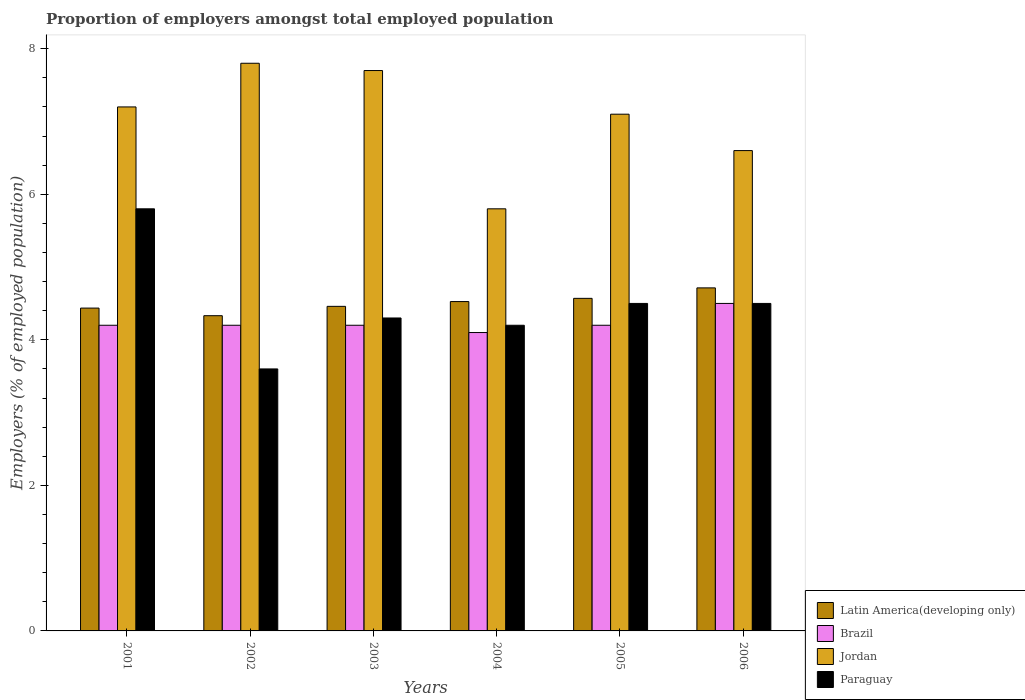How many different coloured bars are there?
Provide a short and direct response. 4. How many bars are there on the 1st tick from the left?
Your answer should be very brief. 4. What is the label of the 3rd group of bars from the left?
Keep it short and to the point. 2003. What is the proportion of employers in Brazil in 2006?
Provide a succinct answer. 4.5. Across all years, what is the maximum proportion of employers in Jordan?
Provide a short and direct response. 7.8. Across all years, what is the minimum proportion of employers in Latin America(developing only)?
Your response must be concise. 4.33. In which year was the proportion of employers in Paraguay maximum?
Give a very brief answer. 2001. In which year was the proportion of employers in Latin America(developing only) minimum?
Your answer should be compact. 2002. What is the total proportion of employers in Jordan in the graph?
Make the answer very short. 42.2. What is the difference between the proportion of employers in Jordan in 2002 and that in 2004?
Ensure brevity in your answer.  2. What is the difference between the proportion of employers in Brazil in 2003 and the proportion of employers in Paraguay in 2006?
Make the answer very short. -0.3. What is the average proportion of employers in Brazil per year?
Keep it short and to the point. 4.23. In the year 2004, what is the difference between the proportion of employers in Paraguay and proportion of employers in Brazil?
Your response must be concise. 0.1. What is the ratio of the proportion of employers in Brazil in 2002 to that in 2004?
Ensure brevity in your answer.  1.02. Is the proportion of employers in Jordan in 2001 less than that in 2002?
Your answer should be compact. Yes. Is the difference between the proportion of employers in Paraguay in 2003 and 2006 greater than the difference between the proportion of employers in Brazil in 2003 and 2006?
Ensure brevity in your answer.  Yes. What is the difference between the highest and the second highest proportion of employers in Brazil?
Provide a succinct answer. 0.3. What is the difference between the highest and the lowest proportion of employers in Paraguay?
Offer a very short reply. 2.2. In how many years, is the proportion of employers in Latin America(developing only) greater than the average proportion of employers in Latin America(developing only) taken over all years?
Your answer should be compact. 3. Is it the case that in every year, the sum of the proportion of employers in Jordan and proportion of employers in Brazil is greater than the sum of proportion of employers in Paraguay and proportion of employers in Latin America(developing only)?
Give a very brief answer. Yes. What does the 4th bar from the left in 2003 represents?
Ensure brevity in your answer.  Paraguay. What does the 2nd bar from the right in 2006 represents?
Provide a short and direct response. Jordan. Is it the case that in every year, the sum of the proportion of employers in Brazil and proportion of employers in Paraguay is greater than the proportion of employers in Jordan?
Keep it short and to the point. No. How many bars are there?
Your response must be concise. 24. Are all the bars in the graph horizontal?
Keep it short and to the point. No. How many years are there in the graph?
Offer a terse response. 6. Are the values on the major ticks of Y-axis written in scientific E-notation?
Ensure brevity in your answer.  No. Where does the legend appear in the graph?
Your response must be concise. Bottom right. How are the legend labels stacked?
Give a very brief answer. Vertical. What is the title of the graph?
Your response must be concise. Proportion of employers amongst total employed population. What is the label or title of the Y-axis?
Offer a very short reply. Employers (% of employed population). What is the Employers (% of employed population) in Latin America(developing only) in 2001?
Your answer should be very brief. 4.44. What is the Employers (% of employed population) in Brazil in 2001?
Ensure brevity in your answer.  4.2. What is the Employers (% of employed population) of Jordan in 2001?
Offer a very short reply. 7.2. What is the Employers (% of employed population) in Paraguay in 2001?
Provide a succinct answer. 5.8. What is the Employers (% of employed population) in Latin America(developing only) in 2002?
Offer a terse response. 4.33. What is the Employers (% of employed population) of Brazil in 2002?
Your answer should be compact. 4.2. What is the Employers (% of employed population) in Jordan in 2002?
Your response must be concise. 7.8. What is the Employers (% of employed population) in Paraguay in 2002?
Provide a succinct answer. 3.6. What is the Employers (% of employed population) of Latin America(developing only) in 2003?
Your answer should be very brief. 4.46. What is the Employers (% of employed population) in Brazil in 2003?
Make the answer very short. 4.2. What is the Employers (% of employed population) in Jordan in 2003?
Offer a very short reply. 7.7. What is the Employers (% of employed population) of Paraguay in 2003?
Offer a very short reply. 4.3. What is the Employers (% of employed population) of Latin America(developing only) in 2004?
Offer a very short reply. 4.53. What is the Employers (% of employed population) of Brazil in 2004?
Offer a terse response. 4.1. What is the Employers (% of employed population) in Jordan in 2004?
Provide a succinct answer. 5.8. What is the Employers (% of employed population) in Paraguay in 2004?
Your answer should be compact. 4.2. What is the Employers (% of employed population) of Latin America(developing only) in 2005?
Your response must be concise. 4.57. What is the Employers (% of employed population) in Brazil in 2005?
Give a very brief answer. 4.2. What is the Employers (% of employed population) in Jordan in 2005?
Make the answer very short. 7.1. What is the Employers (% of employed population) in Paraguay in 2005?
Offer a very short reply. 4.5. What is the Employers (% of employed population) in Latin America(developing only) in 2006?
Ensure brevity in your answer.  4.71. What is the Employers (% of employed population) of Brazil in 2006?
Offer a very short reply. 4.5. What is the Employers (% of employed population) in Jordan in 2006?
Make the answer very short. 6.6. What is the Employers (% of employed population) of Paraguay in 2006?
Your answer should be compact. 4.5. Across all years, what is the maximum Employers (% of employed population) of Latin America(developing only)?
Offer a very short reply. 4.71. Across all years, what is the maximum Employers (% of employed population) of Brazil?
Provide a short and direct response. 4.5. Across all years, what is the maximum Employers (% of employed population) of Jordan?
Provide a short and direct response. 7.8. Across all years, what is the maximum Employers (% of employed population) in Paraguay?
Your answer should be compact. 5.8. Across all years, what is the minimum Employers (% of employed population) of Latin America(developing only)?
Offer a terse response. 4.33. Across all years, what is the minimum Employers (% of employed population) of Brazil?
Provide a succinct answer. 4.1. Across all years, what is the minimum Employers (% of employed population) of Jordan?
Keep it short and to the point. 5.8. Across all years, what is the minimum Employers (% of employed population) of Paraguay?
Your answer should be compact. 3.6. What is the total Employers (% of employed population) in Latin America(developing only) in the graph?
Your answer should be compact. 27.04. What is the total Employers (% of employed population) in Brazil in the graph?
Give a very brief answer. 25.4. What is the total Employers (% of employed population) of Jordan in the graph?
Provide a succinct answer. 42.2. What is the total Employers (% of employed population) in Paraguay in the graph?
Your response must be concise. 26.9. What is the difference between the Employers (% of employed population) in Latin America(developing only) in 2001 and that in 2002?
Provide a short and direct response. 0.1. What is the difference between the Employers (% of employed population) in Paraguay in 2001 and that in 2002?
Provide a short and direct response. 2.2. What is the difference between the Employers (% of employed population) in Latin America(developing only) in 2001 and that in 2003?
Offer a terse response. -0.02. What is the difference between the Employers (% of employed population) in Latin America(developing only) in 2001 and that in 2004?
Ensure brevity in your answer.  -0.09. What is the difference between the Employers (% of employed population) of Brazil in 2001 and that in 2004?
Ensure brevity in your answer.  0.1. What is the difference between the Employers (% of employed population) of Latin America(developing only) in 2001 and that in 2005?
Offer a terse response. -0.13. What is the difference between the Employers (% of employed population) of Paraguay in 2001 and that in 2005?
Offer a terse response. 1.3. What is the difference between the Employers (% of employed population) of Latin America(developing only) in 2001 and that in 2006?
Your answer should be compact. -0.28. What is the difference between the Employers (% of employed population) in Jordan in 2001 and that in 2006?
Your answer should be compact. 0.6. What is the difference between the Employers (% of employed population) in Paraguay in 2001 and that in 2006?
Make the answer very short. 1.3. What is the difference between the Employers (% of employed population) of Latin America(developing only) in 2002 and that in 2003?
Provide a short and direct response. -0.13. What is the difference between the Employers (% of employed population) of Paraguay in 2002 and that in 2003?
Provide a short and direct response. -0.7. What is the difference between the Employers (% of employed population) in Latin America(developing only) in 2002 and that in 2004?
Provide a short and direct response. -0.19. What is the difference between the Employers (% of employed population) of Jordan in 2002 and that in 2004?
Offer a terse response. 2. What is the difference between the Employers (% of employed population) of Paraguay in 2002 and that in 2004?
Give a very brief answer. -0.6. What is the difference between the Employers (% of employed population) in Latin America(developing only) in 2002 and that in 2005?
Provide a succinct answer. -0.24. What is the difference between the Employers (% of employed population) in Brazil in 2002 and that in 2005?
Your answer should be very brief. 0. What is the difference between the Employers (% of employed population) in Jordan in 2002 and that in 2005?
Your response must be concise. 0.7. What is the difference between the Employers (% of employed population) in Paraguay in 2002 and that in 2005?
Give a very brief answer. -0.9. What is the difference between the Employers (% of employed population) in Latin America(developing only) in 2002 and that in 2006?
Keep it short and to the point. -0.38. What is the difference between the Employers (% of employed population) of Jordan in 2002 and that in 2006?
Make the answer very short. 1.2. What is the difference between the Employers (% of employed population) in Paraguay in 2002 and that in 2006?
Offer a terse response. -0.9. What is the difference between the Employers (% of employed population) in Latin America(developing only) in 2003 and that in 2004?
Provide a succinct answer. -0.07. What is the difference between the Employers (% of employed population) in Brazil in 2003 and that in 2004?
Your response must be concise. 0.1. What is the difference between the Employers (% of employed population) of Jordan in 2003 and that in 2004?
Provide a short and direct response. 1.9. What is the difference between the Employers (% of employed population) of Paraguay in 2003 and that in 2004?
Offer a terse response. 0.1. What is the difference between the Employers (% of employed population) of Latin America(developing only) in 2003 and that in 2005?
Your answer should be compact. -0.11. What is the difference between the Employers (% of employed population) in Latin America(developing only) in 2003 and that in 2006?
Ensure brevity in your answer.  -0.25. What is the difference between the Employers (% of employed population) in Jordan in 2003 and that in 2006?
Provide a short and direct response. 1.1. What is the difference between the Employers (% of employed population) of Latin America(developing only) in 2004 and that in 2005?
Offer a terse response. -0.04. What is the difference between the Employers (% of employed population) of Paraguay in 2004 and that in 2005?
Provide a succinct answer. -0.3. What is the difference between the Employers (% of employed population) of Latin America(developing only) in 2004 and that in 2006?
Your answer should be very brief. -0.19. What is the difference between the Employers (% of employed population) in Brazil in 2004 and that in 2006?
Offer a very short reply. -0.4. What is the difference between the Employers (% of employed population) in Latin America(developing only) in 2005 and that in 2006?
Keep it short and to the point. -0.14. What is the difference between the Employers (% of employed population) of Jordan in 2005 and that in 2006?
Give a very brief answer. 0.5. What is the difference between the Employers (% of employed population) in Latin America(developing only) in 2001 and the Employers (% of employed population) in Brazil in 2002?
Your response must be concise. 0.24. What is the difference between the Employers (% of employed population) in Latin America(developing only) in 2001 and the Employers (% of employed population) in Jordan in 2002?
Your response must be concise. -3.36. What is the difference between the Employers (% of employed population) in Latin America(developing only) in 2001 and the Employers (% of employed population) in Paraguay in 2002?
Make the answer very short. 0.84. What is the difference between the Employers (% of employed population) of Latin America(developing only) in 2001 and the Employers (% of employed population) of Brazil in 2003?
Provide a succinct answer. 0.24. What is the difference between the Employers (% of employed population) in Latin America(developing only) in 2001 and the Employers (% of employed population) in Jordan in 2003?
Your answer should be compact. -3.26. What is the difference between the Employers (% of employed population) in Latin America(developing only) in 2001 and the Employers (% of employed population) in Paraguay in 2003?
Your answer should be very brief. 0.14. What is the difference between the Employers (% of employed population) in Brazil in 2001 and the Employers (% of employed population) in Jordan in 2003?
Your answer should be very brief. -3.5. What is the difference between the Employers (% of employed population) of Latin America(developing only) in 2001 and the Employers (% of employed population) of Brazil in 2004?
Give a very brief answer. 0.34. What is the difference between the Employers (% of employed population) in Latin America(developing only) in 2001 and the Employers (% of employed population) in Jordan in 2004?
Offer a very short reply. -1.36. What is the difference between the Employers (% of employed population) in Latin America(developing only) in 2001 and the Employers (% of employed population) in Paraguay in 2004?
Offer a very short reply. 0.24. What is the difference between the Employers (% of employed population) of Brazil in 2001 and the Employers (% of employed population) of Paraguay in 2004?
Keep it short and to the point. 0. What is the difference between the Employers (% of employed population) of Latin America(developing only) in 2001 and the Employers (% of employed population) of Brazil in 2005?
Keep it short and to the point. 0.24. What is the difference between the Employers (% of employed population) of Latin America(developing only) in 2001 and the Employers (% of employed population) of Jordan in 2005?
Provide a short and direct response. -2.66. What is the difference between the Employers (% of employed population) of Latin America(developing only) in 2001 and the Employers (% of employed population) of Paraguay in 2005?
Offer a terse response. -0.06. What is the difference between the Employers (% of employed population) in Brazil in 2001 and the Employers (% of employed population) in Paraguay in 2005?
Keep it short and to the point. -0.3. What is the difference between the Employers (% of employed population) in Latin America(developing only) in 2001 and the Employers (% of employed population) in Brazil in 2006?
Provide a succinct answer. -0.06. What is the difference between the Employers (% of employed population) of Latin America(developing only) in 2001 and the Employers (% of employed population) of Jordan in 2006?
Ensure brevity in your answer.  -2.16. What is the difference between the Employers (% of employed population) in Latin America(developing only) in 2001 and the Employers (% of employed population) in Paraguay in 2006?
Ensure brevity in your answer.  -0.06. What is the difference between the Employers (% of employed population) in Brazil in 2001 and the Employers (% of employed population) in Paraguay in 2006?
Make the answer very short. -0.3. What is the difference between the Employers (% of employed population) of Latin America(developing only) in 2002 and the Employers (% of employed population) of Brazil in 2003?
Provide a short and direct response. 0.13. What is the difference between the Employers (% of employed population) of Latin America(developing only) in 2002 and the Employers (% of employed population) of Jordan in 2003?
Ensure brevity in your answer.  -3.37. What is the difference between the Employers (% of employed population) of Latin America(developing only) in 2002 and the Employers (% of employed population) of Paraguay in 2003?
Provide a short and direct response. 0.03. What is the difference between the Employers (% of employed population) in Brazil in 2002 and the Employers (% of employed population) in Jordan in 2003?
Your answer should be very brief. -3.5. What is the difference between the Employers (% of employed population) of Latin America(developing only) in 2002 and the Employers (% of employed population) of Brazil in 2004?
Ensure brevity in your answer.  0.23. What is the difference between the Employers (% of employed population) in Latin America(developing only) in 2002 and the Employers (% of employed population) in Jordan in 2004?
Provide a short and direct response. -1.47. What is the difference between the Employers (% of employed population) of Latin America(developing only) in 2002 and the Employers (% of employed population) of Paraguay in 2004?
Provide a short and direct response. 0.13. What is the difference between the Employers (% of employed population) of Brazil in 2002 and the Employers (% of employed population) of Jordan in 2004?
Offer a very short reply. -1.6. What is the difference between the Employers (% of employed population) in Brazil in 2002 and the Employers (% of employed population) in Paraguay in 2004?
Provide a short and direct response. 0. What is the difference between the Employers (% of employed population) in Jordan in 2002 and the Employers (% of employed population) in Paraguay in 2004?
Keep it short and to the point. 3.6. What is the difference between the Employers (% of employed population) in Latin America(developing only) in 2002 and the Employers (% of employed population) in Brazil in 2005?
Ensure brevity in your answer.  0.13. What is the difference between the Employers (% of employed population) in Latin America(developing only) in 2002 and the Employers (% of employed population) in Jordan in 2005?
Provide a succinct answer. -2.77. What is the difference between the Employers (% of employed population) of Latin America(developing only) in 2002 and the Employers (% of employed population) of Paraguay in 2005?
Your answer should be very brief. -0.17. What is the difference between the Employers (% of employed population) in Brazil in 2002 and the Employers (% of employed population) in Jordan in 2005?
Your answer should be very brief. -2.9. What is the difference between the Employers (% of employed population) in Jordan in 2002 and the Employers (% of employed population) in Paraguay in 2005?
Make the answer very short. 3.3. What is the difference between the Employers (% of employed population) of Latin America(developing only) in 2002 and the Employers (% of employed population) of Brazil in 2006?
Make the answer very short. -0.17. What is the difference between the Employers (% of employed population) of Latin America(developing only) in 2002 and the Employers (% of employed population) of Jordan in 2006?
Your answer should be very brief. -2.27. What is the difference between the Employers (% of employed population) of Latin America(developing only) in 2002 and the Employers (% of employed population) of Paraguay in 2006?
Ensure brevity in your answer.  -0.17. What is the difference between the Employers (% of employed population) of Brazil in 2002 and the Employers (% of employed population) of Jordan in 2006?
Your answer should be compact. -2.4. What is the difference between the Employers (% of employed population) of Brazil in 2002 and the Employers (% of employed population) of Paraguay in 2006?
Ensure brevity in your answer.  -0.3. What is the difference between the Employers (% of employed population) of Latin America(developing only) in 2003 and the Employers (% of employed population) of Brazil in 2004?
Keep it short and to the point. 0.36. What is the difference between the Employers (% of employed population) in Latin America(developing only) in 2003 and the Employers (% of employed population) in Jordan in 2004?
Ensure brevity in your answer.  -1.34. What is the difference between the Employers (% of employed population) of Latin America(developing only) in 2003 and the Employers (% of employed population) of Paraguay in 2004?
Your answer should be compact. 0.26. What is the difference between the Employers (% of employed population) in Brazil in 2003 and the Employers (% of employed population) in Jordan in 2004?
Your answer should be very brief. -1.6. What is the difference between the Employers (% of employed population) in Brazil in 2003 and the Employers (% of employed population) in Paraguay in 2004?
Give a very brief answer. 0. What is the difference between the Employers (% of employed population) in Latin America(developing only) in 2003 and the Employers (% of employed population) in Brazil in 2005?
Keep it short and to the point. 0.26. What is the difference between the Employers (% of employed population) of Latin America(developing only) in 2003 and the Employers (% of employed population) of Jordan in 2005?
Provide a short and direct response. -2.64. What is the difference between the Employers (% of employed population) in Latin America(developing only) in 2003 and the Employers (% of employed population) in Paraguay in 2005?
Keep it short and to the point. -0.04. What is the difference between the Employers (% of employed population) of Latin America(developing only) in 2003 and the Employers (% of employed population) of Brazil in 2006?
Give a very brief answer. -0.04. What is the difference between the Employers (% of employed population) of Latin America(developing only) in 2003 and the Employers (% of employed population) of Jordan in 2006?
Provide a short and direct response. -2.14. What is the difference between the Employers (% of employed population) of Latin America(developing only) in 2003 and the Employers (% of employed population) of Paraguay in 2006?
Provide a short and direct response. -0.04. What is the difference between the Employers (% of employed population) of Brazil in 2003 and the Employers (% of employed population) of Jordan in 2006?
Make the answer very short. -2.4. What is the difference between the Employers (% of employed population) of Brazil in 2003 and the Employers (% of employed population) of Paraguay in 2006?
Keep it short and to the point. -0.3. What is the difference between the Employers (% of employed population) of Jordan in 2003 and the Employers (% of employed population) of Paraguay in 2006?
Offer a very short reply. 3.2. What is the difference between the Employers (% of employed population) of Latin America(developing only) in 2004 and the Employers (% of employed population) of Brazil in 2005?
Give a very brief answer. 0.33. What is the difference between the Employers (% of employed population) of Latin America(developing only) in 2004 and the Employers (% of employed population) of Jordan in 2005?
Keep it short and to the point. -2.57. What is the difference between the Employers (% of employed population) of Latin America(developing only) in 2004 and the Employers (% of employed population) of Paraguay in 2005?
Offer a terse response. 0.03. What is the difference between the Employers (% of employed population) in Latin America(developing only) in 2004 and the Employers (% of employed population) in Brazil in 2006?
Your answer should be compact. 0.03. What is the difference between the Employers (% of employed population) in Latin America(developing only) in 2004 and the Employers (% of employed population) in Jordan in 2006?
Your answer should be very brief. -2.07. What is the difference between the Employers (% of employed population) in Latin America(developing only) in 2004 and the Employers (% of employed population) in Paraguay in 2006?
Ensure brevity in your answer.  0.03. What is the difference between the Employers (% of employed population) in Latin America(developing only) in 2005 and the Employers (% of employed population) in Brazil in 2006?
Make the answer very short. 0.07. What is the difference between the Employers (% of employed population) in Latin America(developing only) in 2005 and the Employers (% of employed population) in Jordan in 2006?
Provide a succinct answer. -2.03. What is the difference between the Employers (% of employed population) of Latin America(developing only) in 2005 and the Employers (% of employed population) of Paraguay in 2006?
Provide a succinct answer. 0.07. What is the difference between the Employers (% of employed population) of Jordan in 2005 and the Employers (% of employed population) of Paraguay in 2006?
Your answer should be compact. 2.6. What is the average Employers (% of employed population) in Latin America(developing only) per year?
Your answer should be very brief. 4.51. What is the average Employers (% of employed population) of Brazil per year?
Give a very brief answer. 4.23. What is the average Employers (% of employed population) of Jordan per year?
Your answer should be very brief. 7.03. What is the average Employers (% of employed population) in Paraguay per year?
Offer a very short reply. 4.48. In the year 2001, what is the difference between the Employers (% of employed population) of Latin America(developing only) and Employers (% of employed population) of Brazil?
Offer a terse response. 0.24. In the year 2001, what is the difference between the Employers (% of employed population) in Latin America(developing only) and Employers (% of employed population) in Jordan?
Your response must be concise. -2.76. In the year 2001, what is the difference between the Employers (% of employed population) of Latin America(developing only) and Employers (% of employed population) of Paraguay?
Your response must be concise. -1.36. In the year 2002, what is the difference between the Employers (% of employed population) of Latin America(developing only) and Employers (% of employed population) of Brazil?
Provide a succinct answer. 0.13. In the year 2002, what is the difference between the Employers (% of employed population) in Latin America(developing only) and Employers (% of employed population) in Jordan?
Your answer should be very brief. -3.47. In the year 2002, what is the difference between the Employers (% of employed population) of Latin America(developing only) and Employers (% of employed population) of Paraguay?
Ensure brevity in your answer.  0.73. In the year 2002, what is the difference between the Employers (% of employed population) in Brazil and Employers (% of employed population) in Paraguay?
Your response must be concise. 0.6. In the year 2002, what is the difference between the Employers (% of employed population) of Jordan and Employers (% of employed population) of Paraguay?
Keep it short and to the point. 4.2. In the year 2003, what is the difference between the Employers (% of employed population) in Latin America(developing only) and Employers (% of employed population) in Brazil?
Offer a terse response. 0.26. In the year 2003, what is the difference between the Employers (% of employed population) of Latin America(developing only) and Employers (% of employed population) of Jordan?
Your response must be concise. -3.24. In the year 2003, what is the difference between the Employers (% of employed population) of Latin America(developing only) and Employers (% of employed population) of Paraguay?
Offer a very short reply. 0.16. In the year 2004, what is the difference between the Employers (% of employed population) of Latin America(developing only) and Employers (% of employed population) of Brazil?
Ensure brevity in your answer.  0.43. In the year 2004, what is the difference between the Employers (% of employed population) of Latin America(developing only) and Employers (% of employed population) of Jordan?
Provide a short and direct response. -1.27. In the year 2004, what is the difference between the Employers (% of employed population) in Latin America(developing only) and Employers (% of employed population) in Paraguay?
Offer a terse response. 0.33. In the year 2004, what is the difference between the Employers (% of employed population) in Brazil and Employers (% of employed population) in Jordan?
Your response must be concise. -1.7. In the year 2004, what is the difference between the Employers (% of employed population) of Brazil and Employers (% of employed population) of Paraguay?
Keep it short and to the point. -0.1. In the year 2005, what is the difference between the Employers (% of employed population) in Latin America(developing only) and Employers (% of employed population) in Brazil?
Provide a succinct answer. 0.37. In the year 2005, what is the difference between the Employers (% of employed population) of Latin America(developing only) and Employers (% of employed population) of Jordan?
Make the answer very short. -2.53. In the year 2005, what is the difference between the Employers (% of employed population) in Latin America(developing only) and Employers (% of employed population) in Paraguay?
Offer a very short reply. 0.07. In the year 2005, what is the difference between the Employers (% of employed population) in Brazil and Employers (% of employed population) in Paraguay?
Offer a terse response. -0.3. In the year 2006, what is the difference between the Employers (% of employed population) of Latin America(developing only) and Employers (% of employed population) of Brazil?
Ensure brevity in your answer.  0.21. In the year 2006, what is the difference between the Employers (% of employed population) of Latin America(developing only) and Employers (% of employed population) of Jordan?
Offer a terse response. -1.89. In the year 2006, what is the difference between the Employers (% of employed population) in Latin America(developing only) and Employers (% of employed population) in Paraguay?
Offer a very short reply. 0.21. In the year 2006, what is the difference between the Employers (% of employed population) of Brazil and Employers (% of employed population) of Jordan?
Make the answer very short. -2.1. What is the ratio of the Employers (% of employed population) in Latin America(developing only) in 2001 to that in 2002?
Keep it short and to the point. 1.02. What is the ratio of the Employers (% of employed population) in Brazil in 2001 to that in 2002?
Make the answer very short. 1. What is the ratio of the Employers (% of employed population) in Jordan in 2001 to that in 2002?
Ensure brevity in your answer.  0.92. What is the ratio of the Employers (% of employed population) in Paraguay in 2001 to that in 2002?
Make the answer very short. 1.61. What is the ratio of the Employers (% of employed population) of Brazil in 2001 to that in 2003?
Ensure brevity in your answer.  1. What is the ratio of the Employers (% of employed population) in Jordan in 2001 to that in 2003?
Ensure brevity in your answer.  0.94. What is the ratio of the Employers (% of employed population) of Paraguay in 2001 to that in 2003?
Your response must be concise. 1.35. What is the ratio of the Employers (% of employed population) in Latin America(developing only) in 2001 to that in 2004?
Offer a very short reply. 0.98. What is the ratio of the Employers (% of employed population) of Brazil in 2001 to that in 2004?
Keep it short and to the point. 1.02. What is the ratio of the Employers (% of employed population) in Jordan in 2001 to that in 2004?
Provide a succinct answer. 1.24. What is the ratio of the Employers (% of employed population) of Paraguay in 2001 to that in 2004?
Make the answer very short. 1.38. What is the ratio of the Employers (% of employed population) of Latin America(developing only) in 2001 to that in 2005?
Offer a terse response. 0.97. What is the ratio of the Employers (% of employed population) in Brazil in 2001 to that in 2005?
Give a very brief answer. 1. What is the ratio of the Employers (% of employed population) of Jordan in 2001 to that in 2005?
Provide a short and direct response. 1.01. What is the ratio of the Employers (% of employed population) in Paraguay in 2001 to that in 2005?
Make the answer very short. 1.29. What is the ratio of the Employers (% of employed population) in Latin America(developing only) in 2001 to that in 2006?
Your response must be concise. 0.94. What is the ratio of the Employers (% of employed population) in Paraguay in 2001 to that in 2006?
Your answer should be very brief. 1.29. What is the ratio of the Employers (% of employed population) of Latin America(developing only) in 2002 to that in 2003?
Your answer should be compact. 0.97. What is the ratio of the Employers (% of employed population) of Brazil in 2002 to that in 2003?
Keep it short and to the point. 1. What is the ratio of the Employers (% of employed population) in Paraguay in 2002 to that in 2003?
Your answer should be very brief. 0.84. What is the ratio of the Employers (% of employed population) of Latin America(developing only) in 2002 to that in 2004?
Your response must be concise. 0.96. What is the ratio of the Employers (% of employed population) of Brazil in 2002 to that in 2004?
Make the answer very short. 1.02. What is the ratio of the Employers (% of employed population) of Jordan in 2002 to that in 2004?
Your response must be concise. 1.34. What is the ratio of the Employers (% of employed population) in Paraguay in 2002 to that in 2004?
Your response must be concise. 0.86. What is the ratio of the Employers (% of employed population) of Latin America(developing only) in 2002 to that in 2005?
Your answer should be very brief. 0.95. What is the ratio of the Employers (% of employed population) of Brazil in 2002 to that in 2005?
Keep it short and to the point. 1. What is the ratio of the Employers (% of employed population) in Jordan in 2002 to that in 2005?
Give a very brief answer. 1.1. What is the ratio of the Employers (% of employed population) of Paraguay in 2002 to that in 2005?
Provide a short and direct response. 0.8. What is the ratio of the Employers (% of employed population) in Latin America(developing only) in 2002 to that in 2006?
Offer a very short reply. 0.92. What is the ratio of the Employers (% of employed population) of Brazil in 2002 to that in 2006?
Provide a succinct answer. 0.93. What is the ratio of the Employers (% of employed population) in Jordan in 2002 to that in 2006?
Your response must be concise. 1.18. What is the ratio of the Employers (% of employed population) in Paraguay in 2002 to that in 2006?
Your answer should be very brief. 0.8. What is the ratio of the Employers (% of employed population) in Latin America(developing only) in 2003 to that in 2004?
Offer a terse response. 0.99. What is the ratio of the Employers (% of employed population) of Brazil in 2003 to that in 2004?
Offer a very short reply. 1.02. What is the ratio of the Employers (% of employed population) in Jordan in 2003 to that in 2004?
Provide a short and direct response. 1.33. What is the ratio of the Employers (% of employed population) in Paraguay in 2003 to that in 2004?
Keep it short and to the point. 1.02. What is the ratio of the Employers (% of employed population) in Latin America(developing only) in 2003 to that in 2005?
Offer a terse response. 0.98. What is the ratio of the Employers (% of employed population) of Jordan in 2003 to that in 2005?
Ensure brevity in your answer.  1.08. What is the ratio of the Employers (% of employed population) in Paraguay in 2003 to that in 2005?
Offer a terse response. 0.96. What is the ratio of the Employers (% of employed population) in Latin America(developing only) in 2003 to that in 2006?
Ensure brevity in your answer.  0.95. What is the ratio of the Employers (% of employed population) of Paraguay in 2003 to that in 2006?
Ensure brevity in your answer.  0.96. What is the ratio of the Employers (% of employed population) of Latin America(developing only) in 2004 to that in 2005?
Your answer should be very brief. 0.99. What is the ratio of the Employers (% of employed population) in Brazil in 2004 to that in 2005?
Offer a very short reply. 0.98. What is the ratio of the Employers (% of employed population) in Jordan in 2004 to that in 2005?
Provide a succinct answer. 0.82. What is the ratio of the Employers (% of employed population) of Paraguay in 2004 to that in 2005?
Give a very brief answer. 0.93. What is the ratio of the Employers (% of employed population) of Latin America(developing only) in 2004 to that in 2006?
Your answer should be very brief. 0.96. What is the ratio of the Employers (% of employed population) in Brazil in 2004 to that in 2006?
Your answer should be very brief. 0.91. What is the ratio of the Employers (% of employed population) of Jordan in 2004 to that in 2006?
Offer a very short reply. 0.88. What is the ratio of the Employers (% of employed population) of Paraguay in 2004 to that in 2006?
Your answer should be very brief. 0.93. What is the ratio of the Employers (% of employed population) in Latin America(developing only) in 2005 to that in 2006?
Your answer should be compact. 0.97. What is the ratio of the Employers (% of employed population) of Jordan in 2005 to that in 2006?
Offer a terse response. 1.08. What is the ratio of the Employers (% of employed population) of Paraguay in 2005 to that in 2006?
Offer a very short reply. 1. What is the difference between the highest and the second highest Employers (% of employed population) of Latin America(developing only)?
Offer a very short reply. 0.14. What is the difference between the highest and the lowest Employers (% of employed population) in Latin America(developing only)?
Make the answer very short. 0.38. What is the difference between the highest and the lowest Employers (% of employed population) of Brazil?
Your answer should be compact. 0.4. 